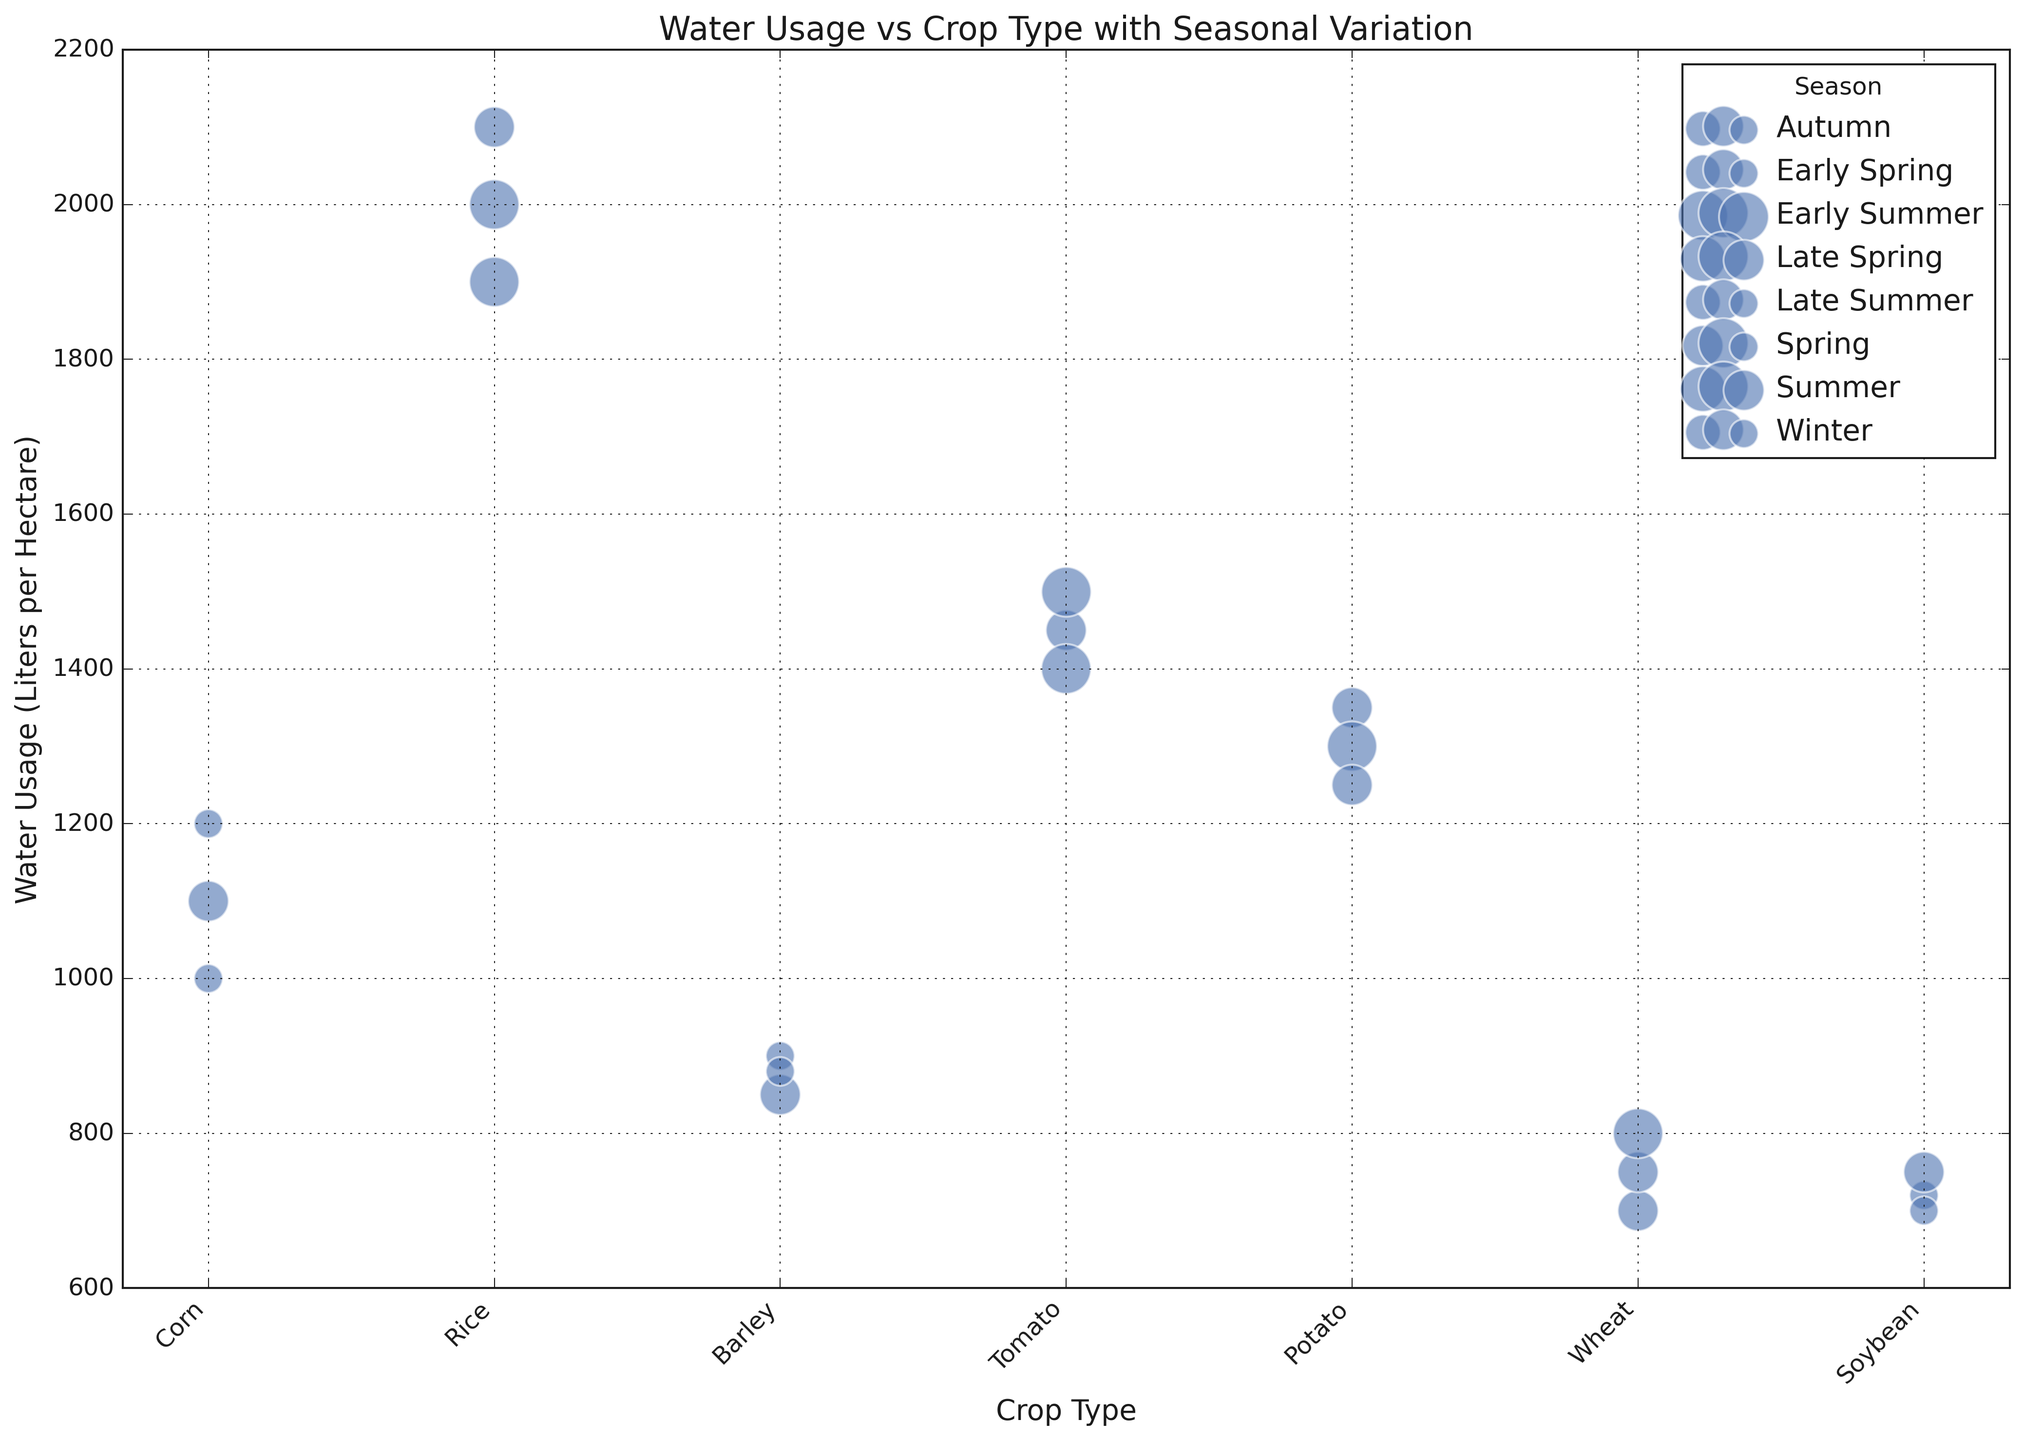What crop type uses the most water in summer? Look at the data points for the summer season and compare the water usage values for each crop type. Notice that rice has the highest water usage with 2000 liters per hectare.
Answer: Rice Which season has the highest average water usage for wheat? Identify the water usage values for wheat in different seasons: Late Spring (750 liters), Early Spring (700 liters), and Summer (800 liters). Average these values for each season: Late Spring = 750, Early Spring = 700, Summer = 800. Summer has the highest average.
Answer: Summer Does corn use more water in early spring or late summer? Compare the water usage values for corn in early spring (1200 liters per hectare) and late summer (1100 liters per hectare). Notice that early spring uses more water.
Answer: Early Spring Which crop type has the smallest bubble size and in which season? Identify the crop types with their bubble sizes. Soybean in Late Summer has the smallest bubble size corresponding to 'Low' impact on biodiversity.
Answer: Soybean, Late Summer Compare the water usage for potato in different seasons. Which season uses the least water? Identify the water usage values for potato in different seasons: Spring (1300 liters), Winter (1250 liters), and Autumn (1350 liters). Winter has the least water usage.
Answer: Winter 